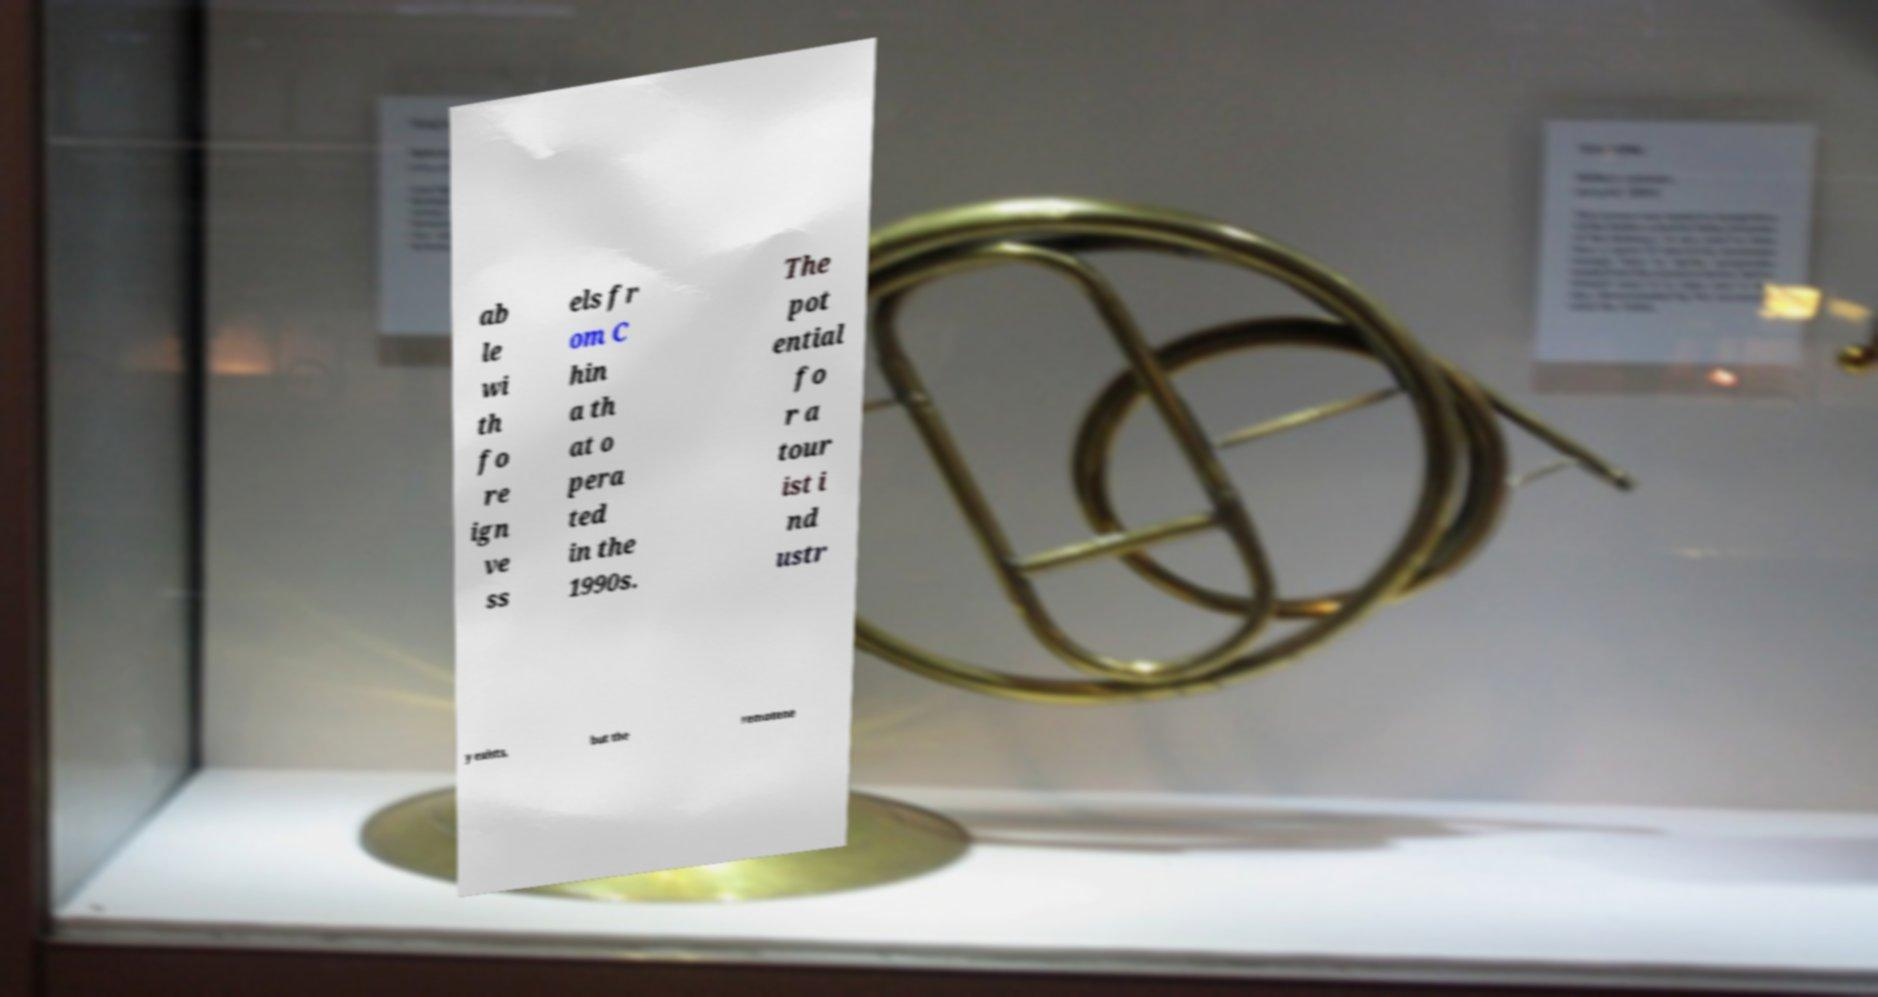I need the written content from this picture converted into text. Can you do that? ab le wi th fo re ign ve ss els fr om C hin a th at o pera ted in the 1990s. The pot ential fo r a tour ist i nd ustr y exists, but the remotene 